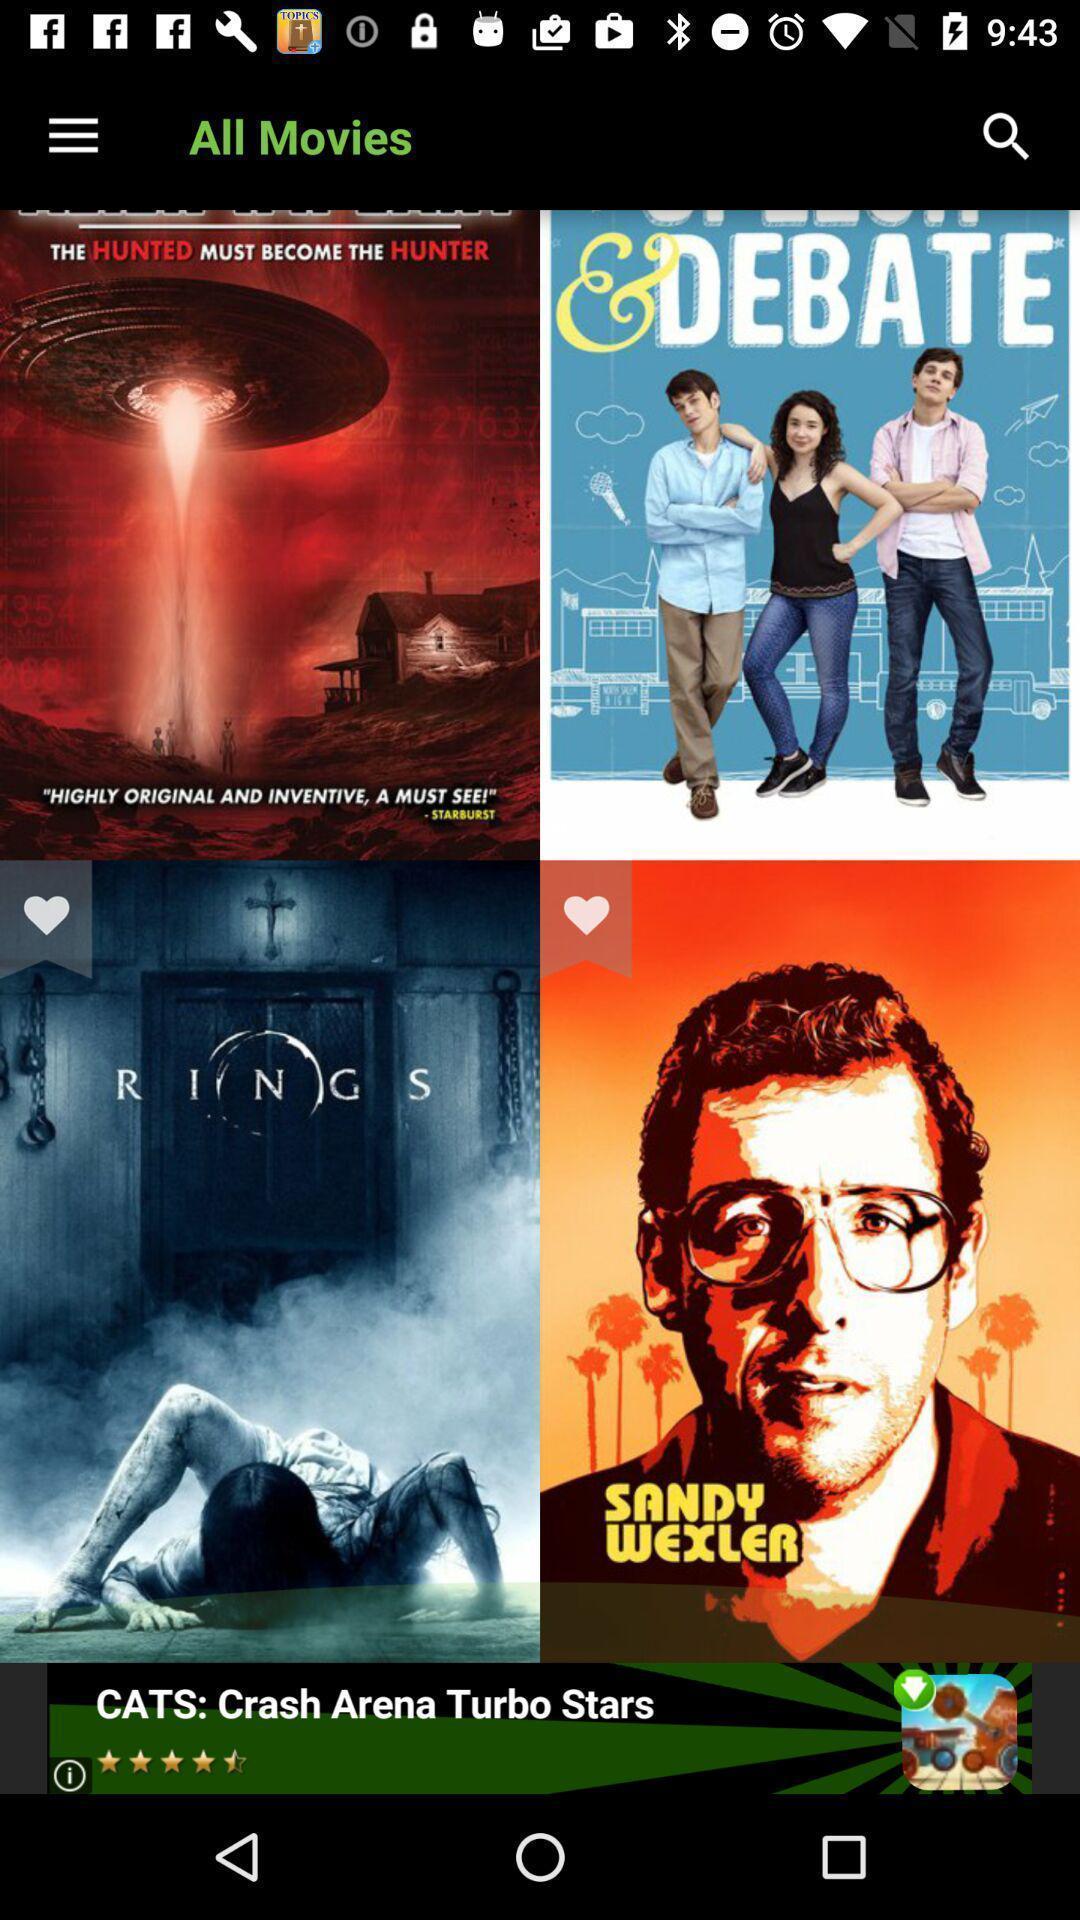Give me a summary of this screen capture. Screen displaying multiple film posters with names. 